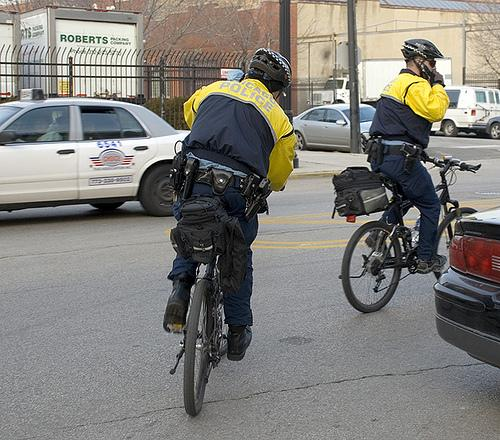What profession are the men on bikes?

Choices:
A) lawyers
B) racers
C) dentists
D) police officers police officers 